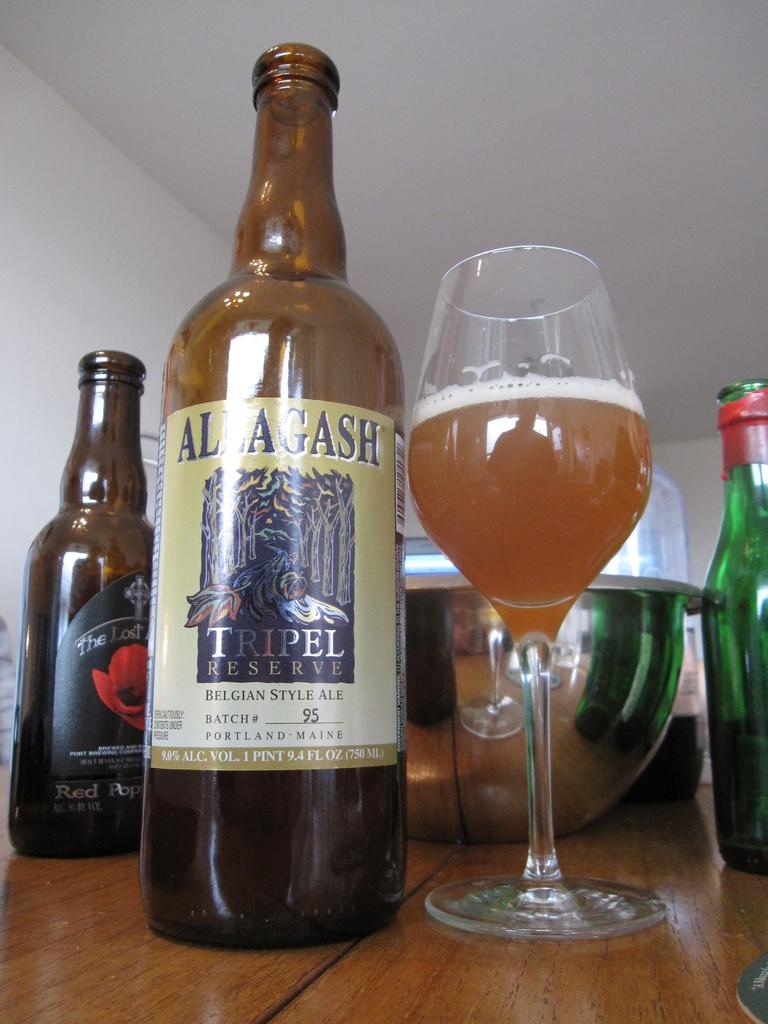What city and state is this beverage from?
Give a very brief answer. Portland maine. What is the name of this drink?
Make the answer very short. Allagash. 